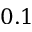<formula> <loc_0><loc_0><loc_500><loc_500>0 . 1</formula> 